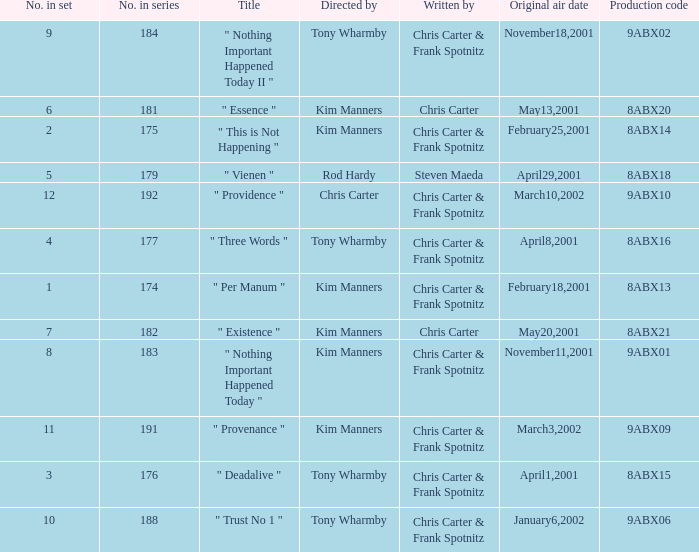What is the episode number that has production code 8abx15? 176.0. 